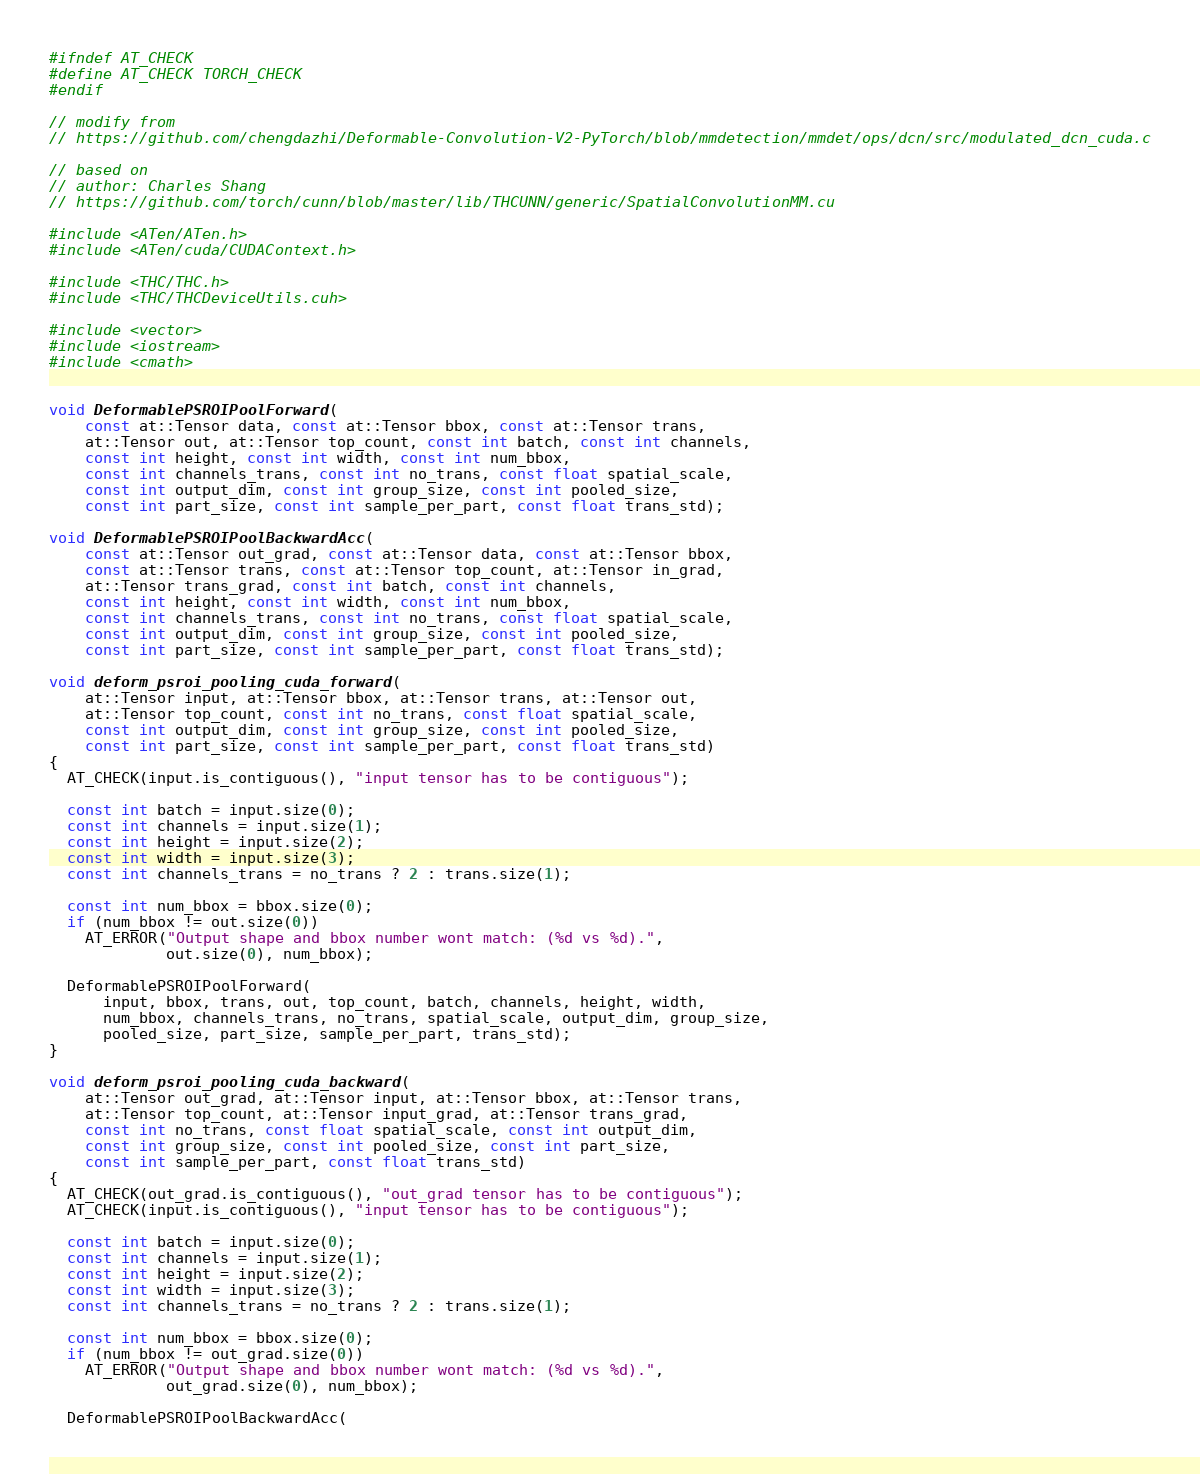<code> <loc_0><loc_0><loc_500><loc_500><_Cuda_>#ifndef AT_CHECK
#define AT_CHECK TORCH_CHECK 
#endif

// modify from
// https://github.com/chengdazhi/Deformable-Convolution-V2-PyTorch/blob/mmdetection/mmdet/ops/dcn/src/modulated_dcn_cuda.c

// based on
// author: Charles Shang
// https://github.com/torch/cunn/blob/master/lib/THCUNN/generic/SpatialConvolutionMM.cu

#include <ATen/ATen.h>
#include <ATen/cuda/CUDAContext.h>

#include <THC/THC.h>
#include <THC/THCDeviceUtils.cuh>

#include <vector>
#include <iostream>
#include <cmath>


void DeformablePSROIPoolForward(
    const at::Tensor data, const at::Tensor bbox, const at::Tensor trans,
    at::Tensor out, at::Tensor top_count, const int batch, const int channels,
    const int height, const int width, const int num_bbox,
    const int channels_trans, const int no_trans, const float spatial_scale,
    const int output_dim, const int group_size, const int pooled_size,
    const int part_size, const int sample_per_part, const float trans_std);

void DeformablePSROIPoolBackwardAcc(
    const at::Tensor out_grad, const at::Tensor data, const at::Tensor bbox,
    const at::Tensor trans, const at::Tensor top_count, at::Tensor in_grad,
    at::Tensor trans_grad, const int batch, const int channels,
    const int height, const int width, const int num_bbox,
    const int channels_trans, const int no_trans, const float spatial_scale,
    const int output_dim, const int group_size, const int pooled_size,
    const int part_size, const int sample_per_part, const float trans_std);

void deform_psroi_pooling_cuda_forward(
    at::Tensor input, at::Tensor bbox, at::Tensor trans, at::Tensor out,
    at::Tensor top_count, const int no_trans, const float spatial_scale,
    const int output_dim, const int group_size, const int pooled_size,
    const int part_size, const int sample_per_part, const float trans_std) 
{
  AT_CHECK(input.is_contiguous(), "input tensor has to be contiguous");

  const int batch = input.size(0);
  const int channels = input.size(1);
  const int height = input.size(2);
  const int width = input.size(3);
  const int channels_trans = no_trans ? 2 : trans.size(1);

  const int num_bbox = bbox.size(0);
  if (num_bbox != out.size(0))
    AT_ERROR("Output shape and bbox number wont match: (%d vs %d).",
             out.size(0), num_bbox);

  DeformablePSROIPoolForward(
      input, bbox, trans, out, top_count, batch, channels, height, width,
      num_bbox, channels_trans, no_trans, spatial_scale, output_dim, group_size,
      pooled_size, part_size, sample_per_part, trans_std);
}

void deform_psroi_pooling_cuda_backward(
    at::Tensor out_grad, at::Tensor input, at::Tensor bbox, at::Tensor trans,
    at::Tensor top_count, at::Tensor input_grad, at::Tensor trans_grad,
    const int no_trans, const float spatial_scale, const int output_dim,
    const int group_size, const int pooled_size, const int part_size,
    const int sample_per_part, const float trans_std) 
{
  AT_CHECK(out_grad.is_contiguous(), "out_grad tensor has to be contiguous");
  AT_CHECK(input.is_contiguous(), "input tensor has to be contiguous");

  const int batch = input.size(0);
  const int channels = input.size(1);
  const int height = input.size(2);
  const int width = input.size(3);
  const int channels_trans = no_trans ? 2 : trans.size(1);

  const int num_bbox = bbox.size(0);
  if (num_bbox != out_grad.size(0))
    AT_ERROR("Output shape and bbox number wont match: (%d vs %d).",
             out_grad.size(0), num_bbox);

  DeformablePSROIPoolBackwardAcc(</code> 